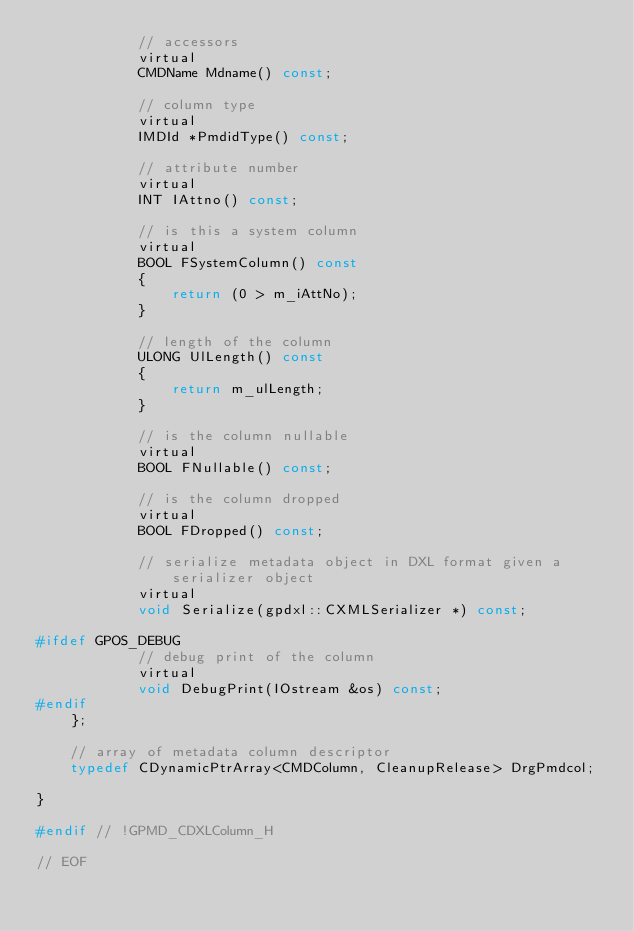Convert code to text. <code><loc_0><loc_0><loc_500><loc_500><_C_>			// accessors
			virtual
			CMDName Mdname() const;
			
			// column type
			virtual 
			IMDId *PmdidType() const;
			
			// attribute number
			virtual
			INT IAttno() const;
			
			// is this a system column
			virtual
			BOOL FSystemColumn() const
			{
				return (0 > m_iAttNo);
			}

			// length of the column
			ULONG UlLength() const
			{
				return m_ulLength;
			}

			// is the column nullable
			virtual
			BOOL FNullable() const;
			
			// is the column dropped
			virtual
			BOOL FDropped() const;
		
			// serialize metadata object in DXL format given a serializer object
			virtual	
			void Serialize(gpdxl::CXMLSerializer *) const;
			
#ifdef GPOS_DEBUG
			// debug print of the column
			virtual
			void DebugPrint(IOstream &os) const;
#endif
	};

	// array of metadata column descriptor
	typedef CDynamicPtrArray<CMDColumn, CleanupRelease> DrgPmdcol;

}

#endif // !GPMD_CDXLColumn_H

// EOF
</code> 